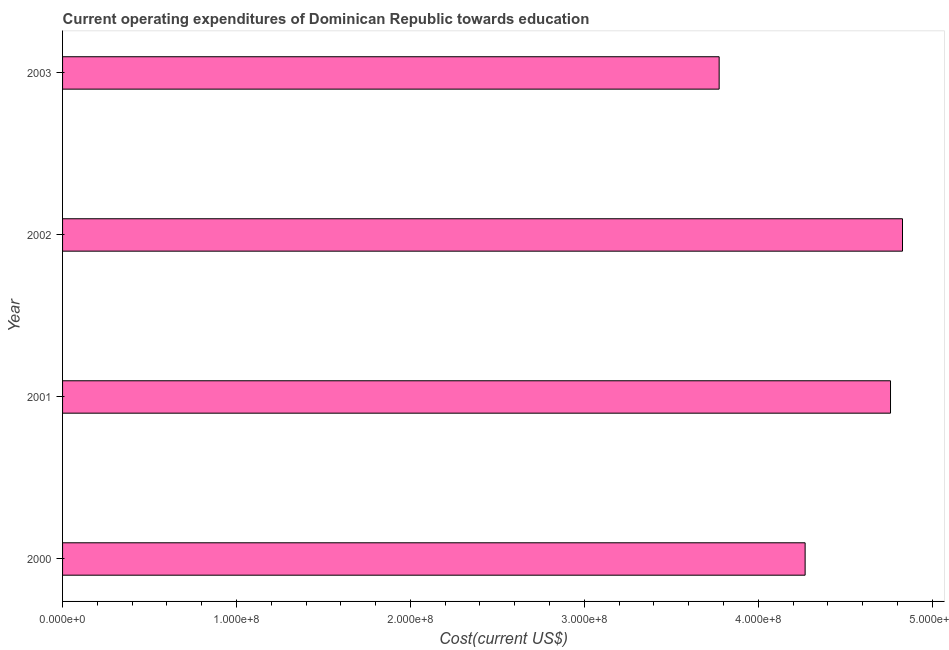What is the title of the graph?
Your answer should be very brief. Current operating expenditures of Dominican Republic towards education. What is the label or title of the X-axis?
Provide a short and direct response. Cost(current US$). What is the label or title of the Y-axis?
Offer a terse response. Year. What is the education expenditure in 2001?
Give a very brief answer. 4.76e+08. Across all years, what is the maximum education expenditure?
Give a very brief answer. 4.83e+08. Across all years, what is the minimum education expenditure?
Give a very brief answer. 3.78e+08. In which year was the education expenditure maximum?
Offer a terse response. 2002. In which year was the education expenditure minimum?
Offer a terse response. 2003. What is the sum of the education expenditure?
Ensure brevity in your answer.  1.76e+09. What is the difference between the education expenditure in 2000 and 2002?
Provide a short and direct response. -5.60e+07. What is the average education expenditure per year?
Keep it short and to the point. 4.41e+08. What is the median education expenditure?
Make the answer very short. 4.52e+08. What is the ratio of the education expenditure in 2002 to that in 2003?
Your answer should be very brief. 1.28. Is the difference between the education expenditure in 2000 and 2001 greater than the difference between any two years?
Keep it short and to the point. No. What is the difference between the highest and the second highest education expenditure?
Keep it short and to the point. 6.89e+06. What is the difference between the highest and the lowest education expenditure?
Your response must be concise. 1.05e+08. How many bars are there?
Provide a short and direct response. 4. What is the difference between two consecutive major ticks on the X-axis?
Ensure brevity in your answer.  1.00e+08. Are the values on the major ticks of X-axis written in scientific E-notation?
Provide a short and direct response. Yes. What is the Cost(current US$) of 2000?
Offer a terse response. 4.27e+08. What is the Cost(current US$) of 2001?
Offer a terse response. 4.76e+08. What is the Cost(current US$) of 2002?
Keep it short and to the point. 4.83e+08. What is the Cost(current US$) of 2003?
Offer a very short reply. 3.78e+08. What is the difference between the Cost(current US$) in 2000 and 2001?
Your answer should be very brief. -4.91e+07. What is the difference between the Cost(current US$) in 2000 and 2002?
Make the answer very short. -5.60e+07. What is the difference between the Cost(current US$) in 2000 and 2003?
Your answer should be compact. 4.94e+07. What is the difference between the Cost(current US$) in 2001 and 2002?
Ensure brevity in your answer.  -6.89e+06. What is the difference between the Cost(current US$) in 2001 and 2003?
Provide a succinct answer. 9.85e+07. What is the difference between the Cost(current US$) in 2002 and 2003?
Make the answer very short. 1.05e+08. What is the ratio of the Cost(current US$) in 2000 to that in 2001?
Keep it short and to the point. 0.9. What is the ratio of the Cost(current US$) in 2000 to that in 2002?
Offer a terse response. 0.88. What is the ratio of the Cost(current US$) in 2000 to that in 2003?
Your answer should be compact. 1.13. What is the ratio of the Cost(current US$) in 2001 to that in 2002?
Give a very brief answer. 0.99. What is the ratio of the Cost(current US$) in 2001 to that in 2003?
Offer a terse response. 1.26. What is the ratio of the Cost(current US$) in 2002 to that in 2003?
Your answer should be very brief. 1.28. 